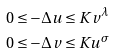Convert formula to latex. <formula><loc_0><loc_0><loc_500><loc_500>& 0 \leq - \Delta u \leq K v ^ { \lambda } \\ & 0 \leq - \Delta v \leq K u ^ { \sigma } \\</formula> 